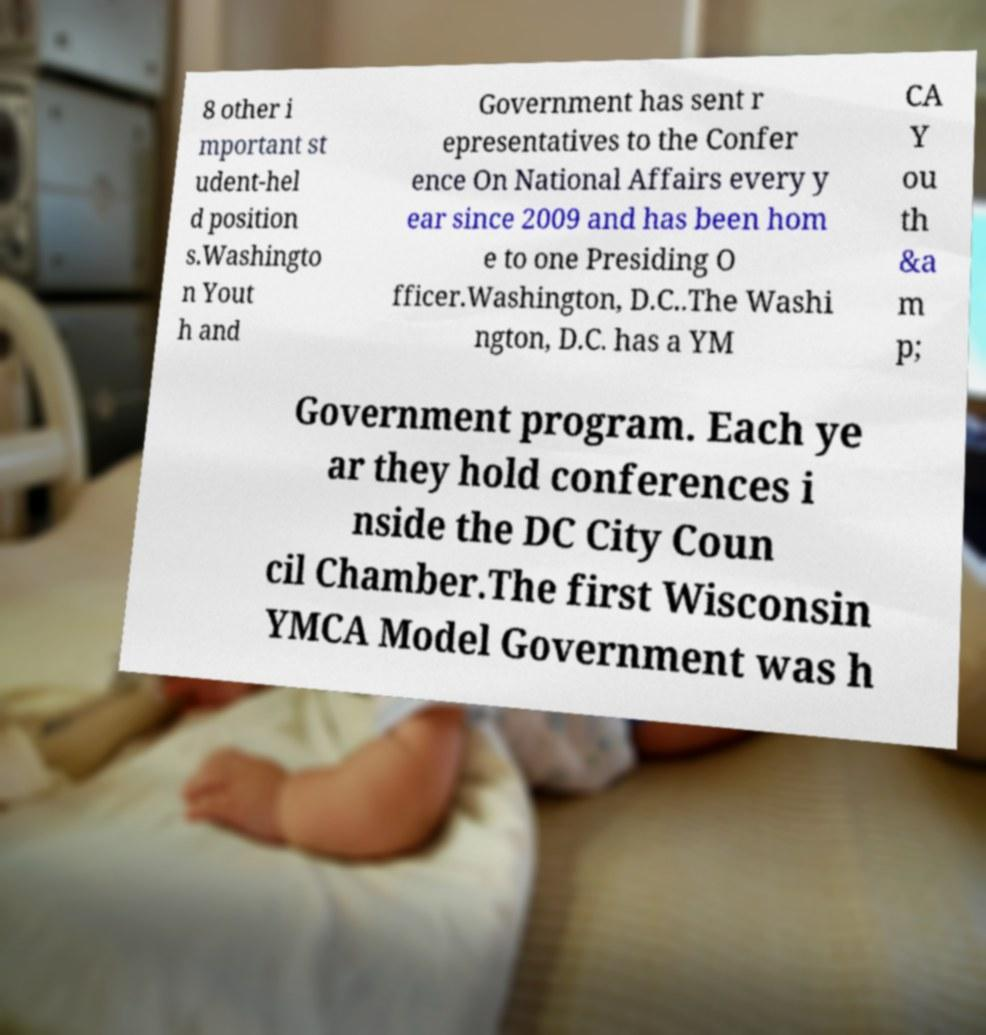Can you read and provide the text displayed in the image?This photo seems to have some interesting text. Can you extract and type it out for me? 8 other i mportant st udent-hel d position s.Washingto n Yout h and Government has sent r epresentatives to the Confer ence On National Affairs every y ear since 2009 and has been hom e to one Presiding O fficer.Washington, D.C..The Washi ngton, D.C. has a YM CA Y ou th &a m p; Government program. Each ye ar they hold conferences i nside the DC City Coun cil Chamber.The first Wisconsin YMCA Model Government was h 